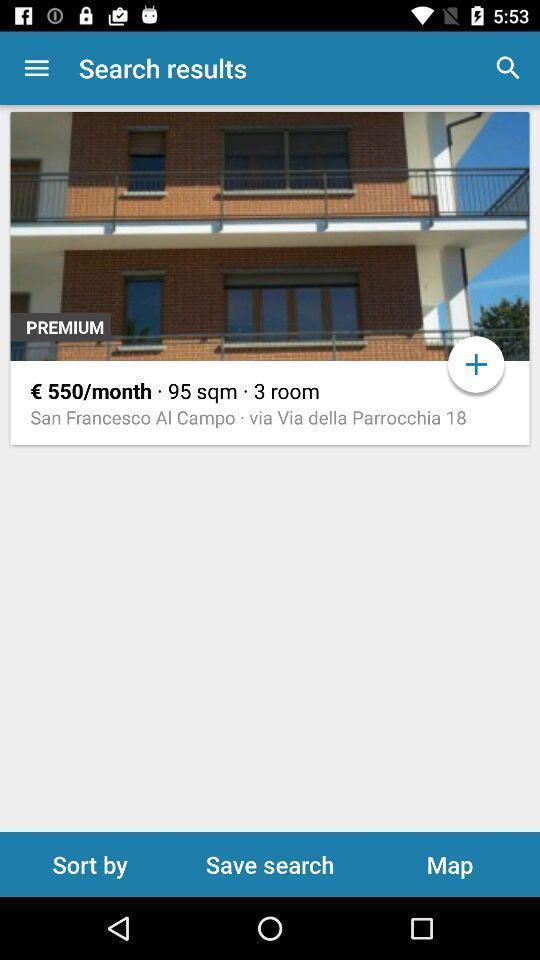Provide a description of this screenshot. Searching a house for rent. 